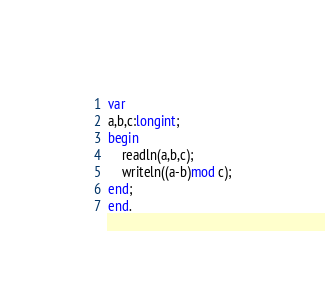<code> <loc_0><loc_0><loc_500><loc_500><_Pascal_>var
a,b,c:longint;
begin
    readln(a,b,c);
    writeln((a-b)mod c);
end;
end.</code> 